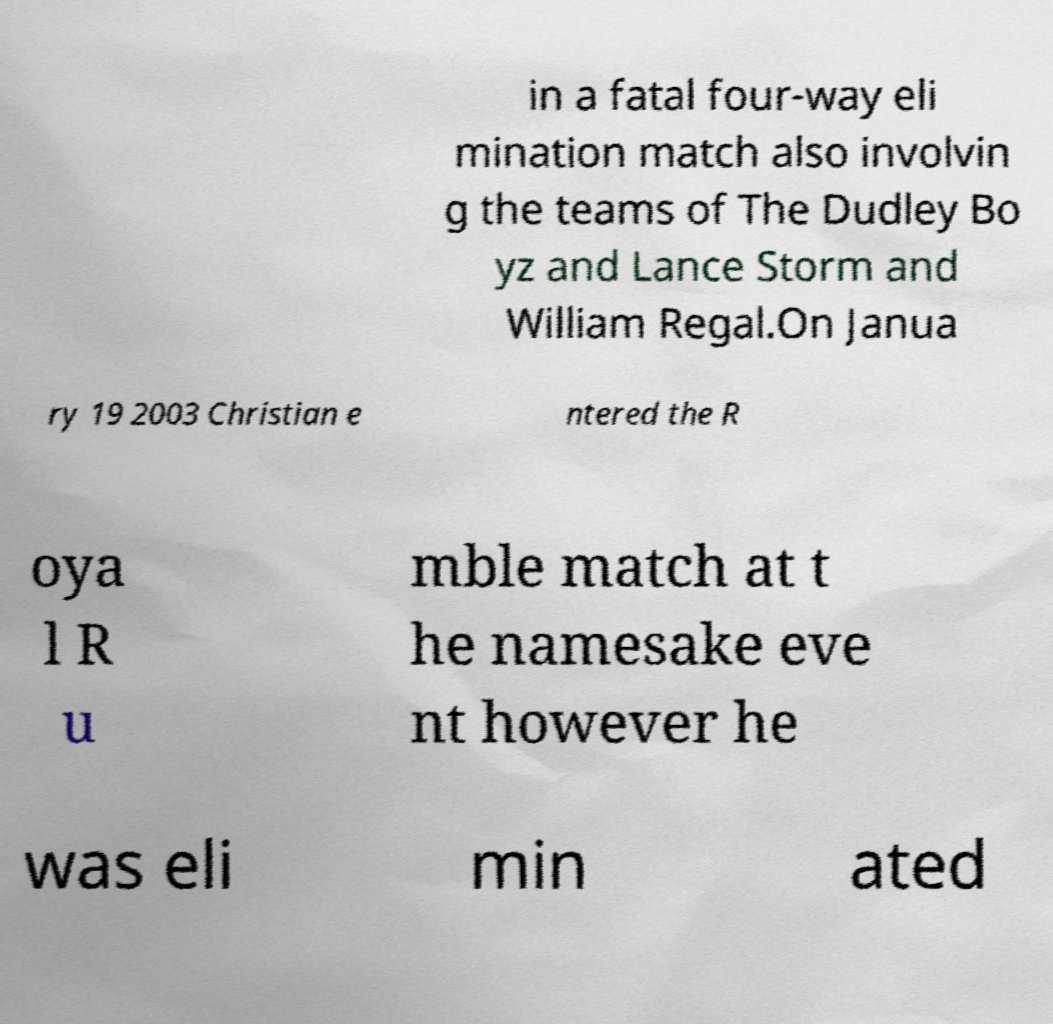Could you extract and type out the text from this image? in a fatal four-way eli mination match also involvin g the teams of The Dudley Bo yz and Lance Storm and William Regal.On Janua ry 19 2003 Christian e ntered the R oya l R u mble match at t he namesake eve nt however he was eli min ated 